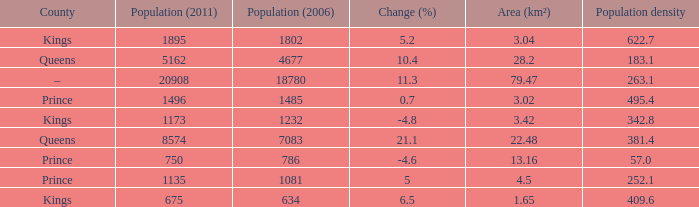What was the Population (2011) when the Population (2006) was less than 7083, and the Population density less than 342.8, and the Change (%) of 5, and an Area (km²) larger than 4.5? 0.0. 